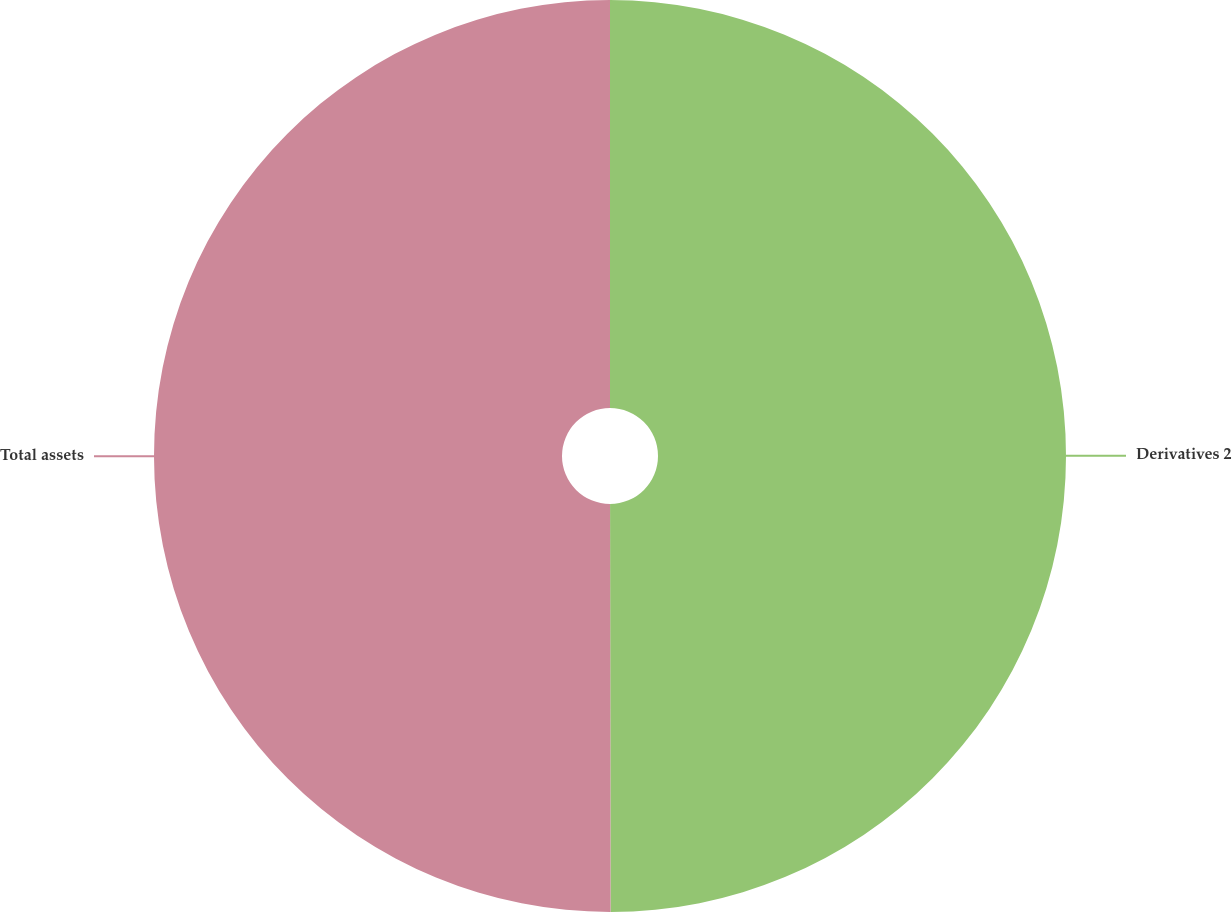<chart> <loc_0><loc_0><loc_500><loc_500><pie_chart><fcel>Derivatives 2<fcel>Total assets<nl><fcel>49.98%<fcel>50.02%<nl></chart> 